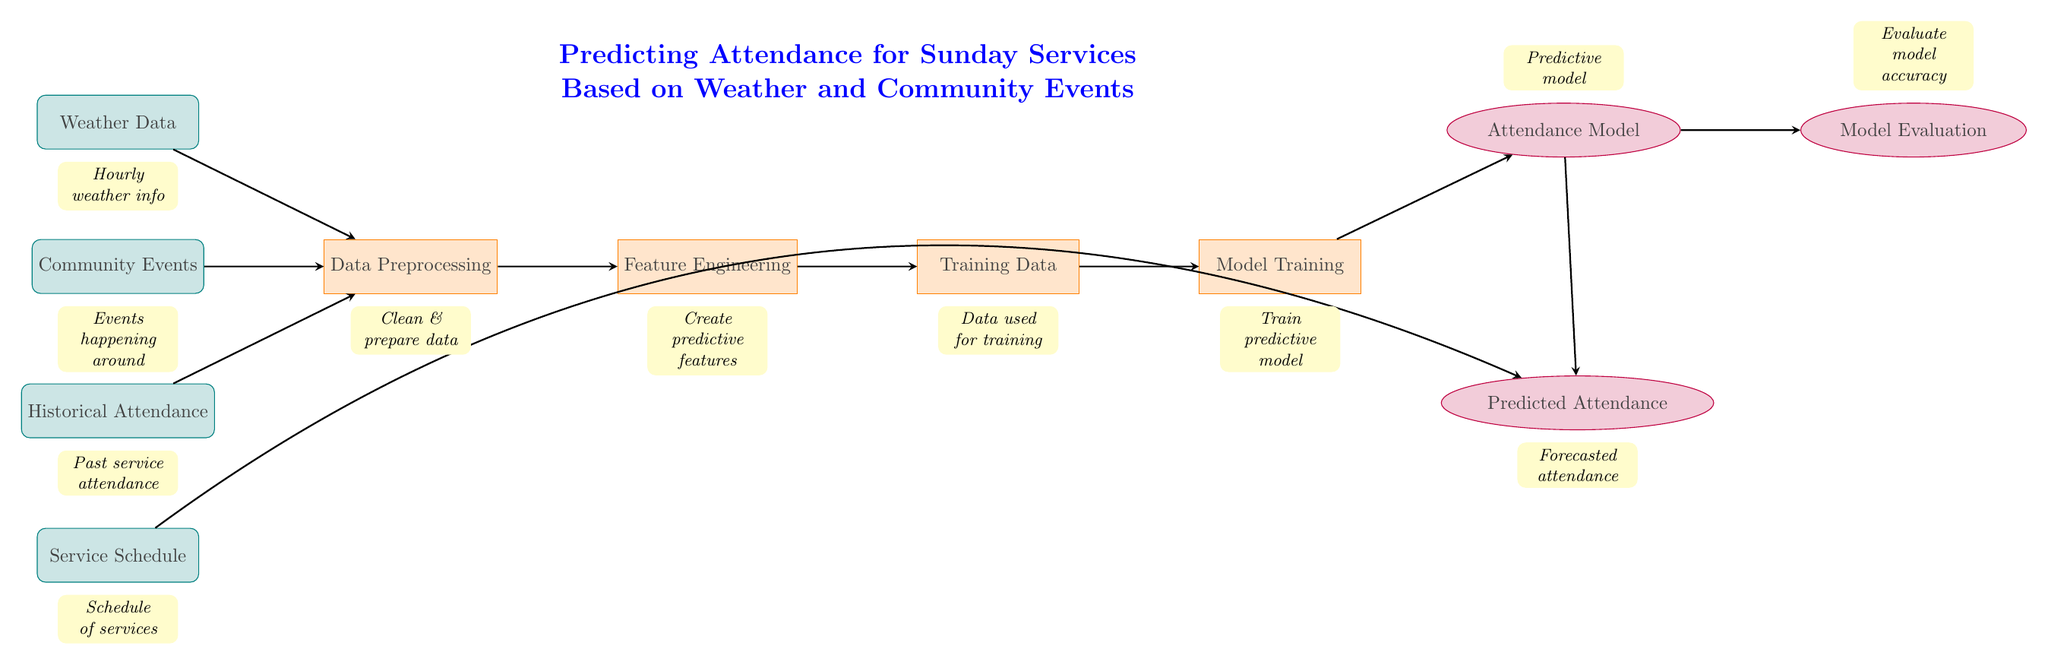What are the main inputs to the process? The main inputs to the process are shown at the beginning of the diagram. They include Weather Data, Community Events, Historical Attendance, and Service Schedule, which are all represented by the input nodes.
Answer: Weather Data, Community Events, Historical Attendance, Service Schedule How many process nodes are there? By reviewing the diagram, we can count the rectangles that represent process nodes. There are four processing nodes labeled Data Preprocessing, Feature Engineering, Training Data, and Model Training.
Answer: Four What is the first step in the model training process? Analyzing the arrows in the diagram, the first step in the model training process after the inputs is the Data Preprocessing stage, which is indicated by the arrow moving from the input nodes to the preprocess node.
Answer: Data Preprocessing Which input is directly connected to the predicted attendance? By following the arrows, we see that the Service Schedule node has a direct connection to the Predicted Attendance output, indicating its influence on attendance predictions.
Answer: Service Schedule What does the Model Evaluation node assess? The Model Evaluation node is placed to the right of the Attendance Model node and is purposed to evaluate the accuracy of the predictive model, as indicated by the description below that node.
Answer: Model accuracy How many arrows are coming out from the Attendance Model node? Looking at the diagram, the Attendance Model node points to two nodes: Model Evaluation and Predicted Attendance. Thus, there are two arrows coming out from the Attendance Model.
Answer: Two Which processing step takes place after Feature Engineering? Following the flow of the diagram from Feature Engineering, the next process step that occurs is Training Data, as shown by the arrow leading from Feature Engineering to the Training Data node.
Answer: Training Data What type of model is being trained? The type of model that is being trained is labeled as Attendance Model, appearing above the Model Training node, indicating that it predicts attendance based on the processed data.
Answer: Attendance Model What happens to the outputs after Model Training? After Model Training, two distinct outputs are produced as indicated by the arrows leading out from the Model Training node: one goes to the Attendance Model and the other to Predicted Attendance, establishing their relationship.
Answer: Attendance Model, Predicted Attendance 